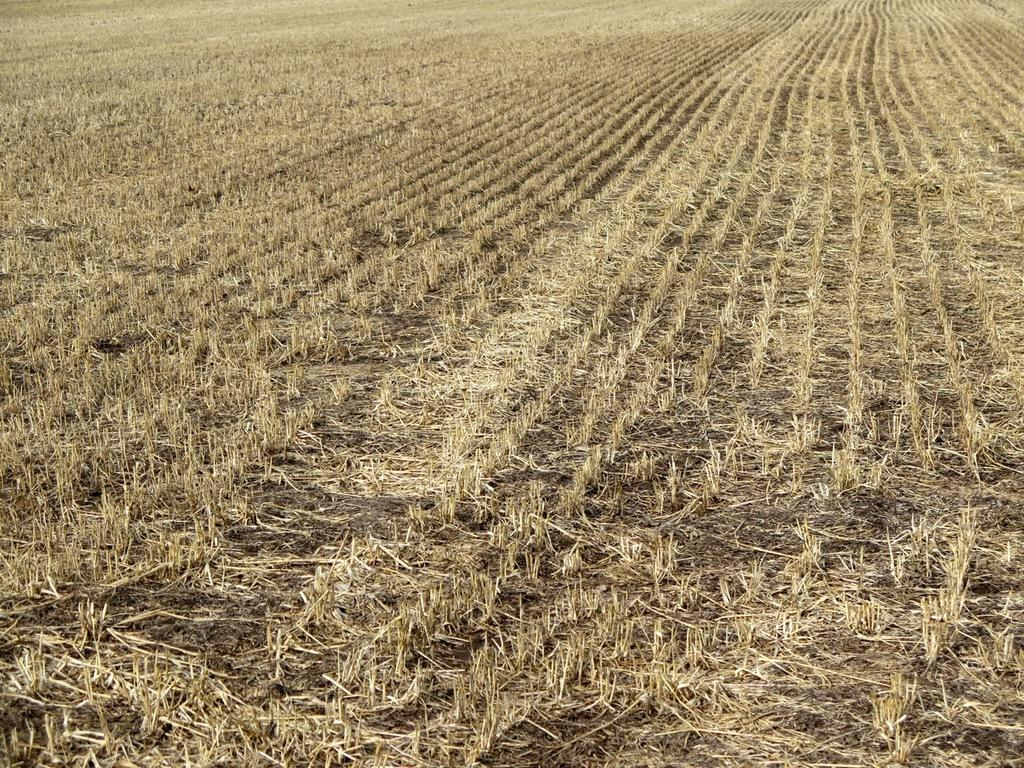What type of ground cover can be seen in the image? There is dried grass on the ground in the image. What color is the dried grass? The grass is in cream color. What type of toothbrush is being used to clean the dried grass in the image? There is no toothbrush present in the image, and the dried grass is not being cleaned. 